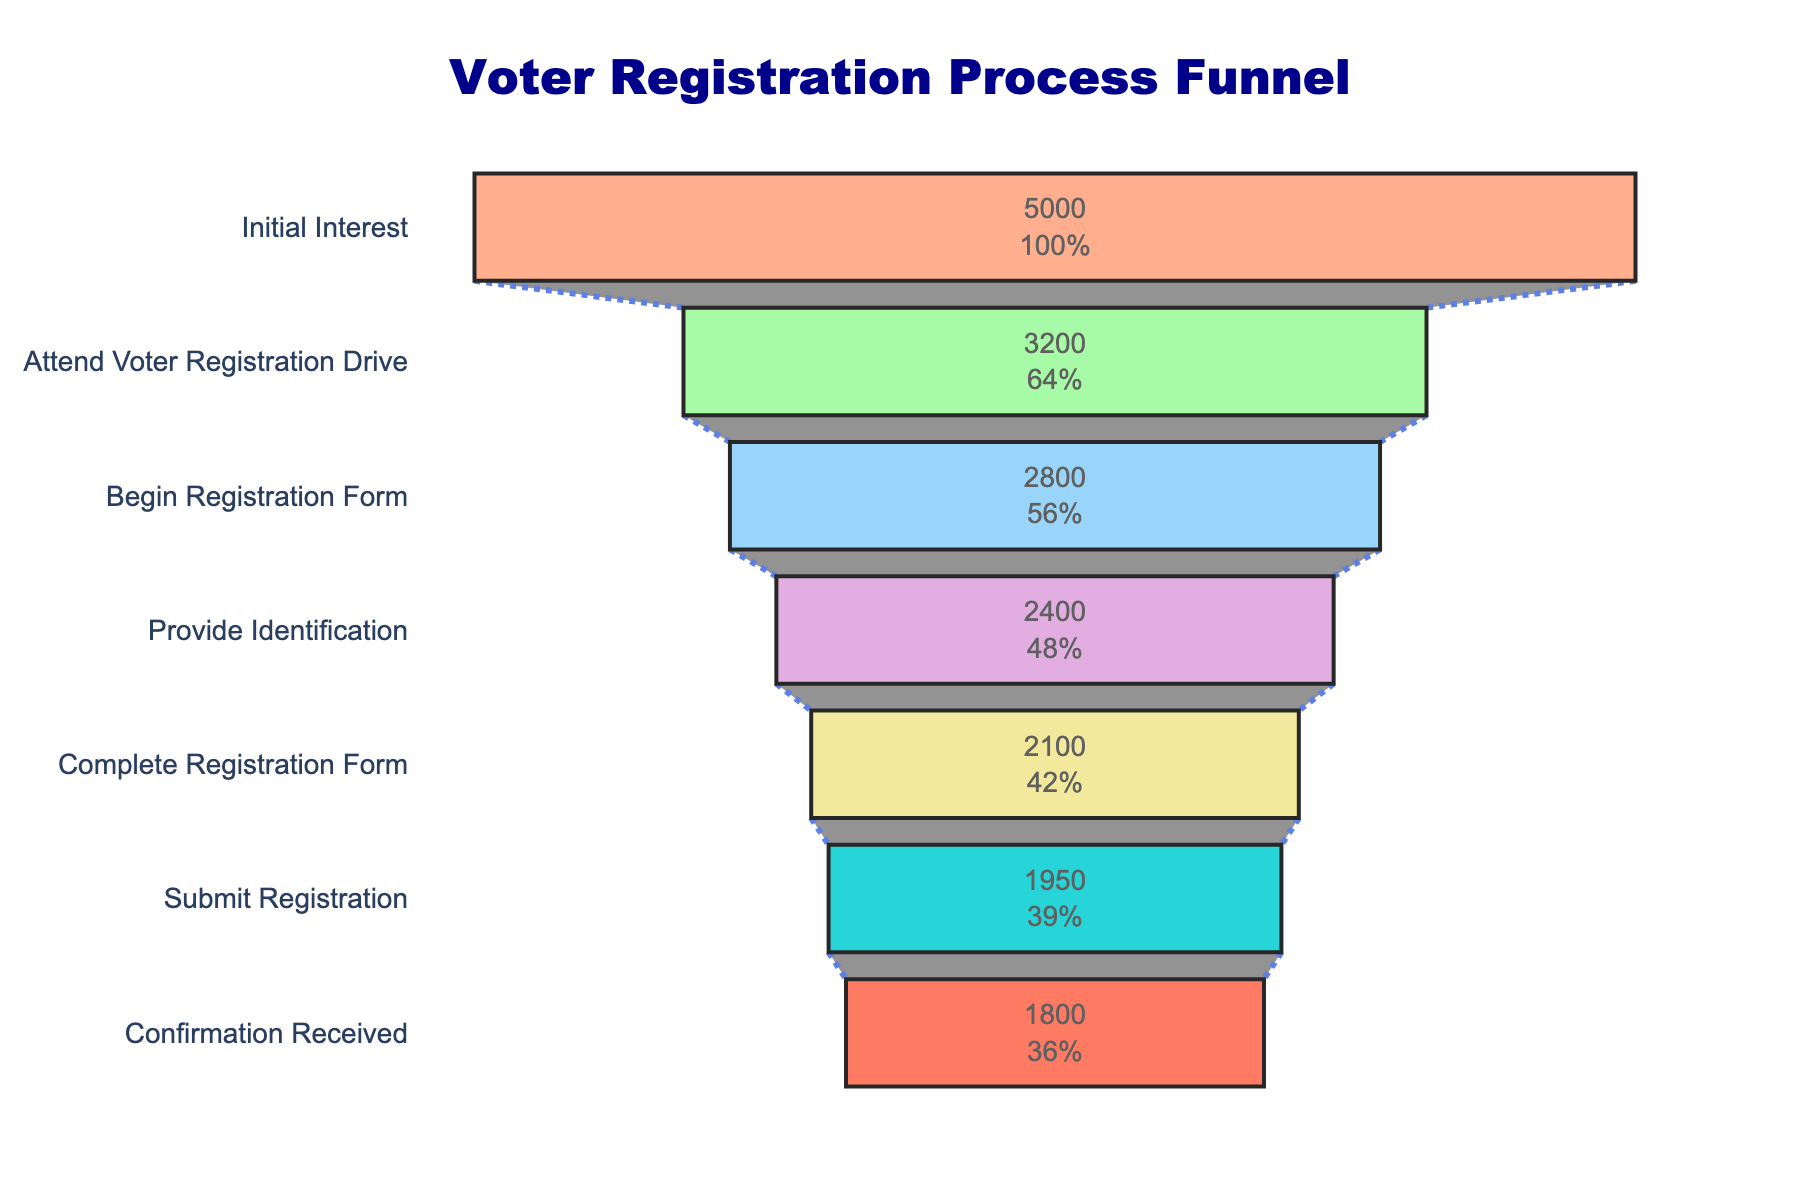What's the title of the figure? The title of the figure is located at the top center and provides a summary of what the figure represents. It reads "Voter Registration Process Funnel".
Answer: Voter Registration Process Funnel What stage has the most significant decrease in the number of people? To find the stage with the most significant decrease, we look for the largest drop in values between successive stages. The largest drop is between "Initial Interest" (5000) and "Attend Voter Registration Drive" (3200), a decrease of 1800 people.
Answer: Attend Voter Registration Drive Which stage has the fewest number of people? To find the stage with the fewest number of people, we examine the values for each stage and identify the smallest value. The smallest value is at the final stage, "Confirmation Received" with 1800 people.
Answer: Confirmation Received What percentage of people who initially showed interest completed the registration form? To find this percentage, we take the number of people who completed the registration form (2100) and divide it by the initial interest (5000), then multiply by 100. (2100/5000) * 100 = 42%.
Answer: 42% How many more people submit their registration than those who provide identification? To determine the difference, subtract the number of people who provide identification (2400) from those who submit registration (1950). 2400 - 1950 = 450.
Answer: 450 What is the average number of people per stage? To calculate the average, sum the number of people across all stages and divide by the number of stages. Sum: 5000 + 3200 + 2800 + 2400 + 2100 + 1950 + 1800 = 19250. Number of stages: 7. Average = 19250 / 7 ≈ 2750.
Answer: 2750 Which stage shows the smallest drop in the number of people from the previous stage? To find this, we calculate the difference between each successive stage and identify the smallest drop. "Complete Registration Form" to "Submit Registration" is 2100 to 1950, a decrease of 150, which is the smallest drop.
Answer: Submit Registration What percentage of people who provided identification received confirmation? To find this percentage, we divide the number of people who received confirmation (1800) by those who provided identification (2400) and multiply by 100. (1800/2400) * 100 = 75%.
Answer: 75% What stage follows "Begin Registration Form"? To identify the stage following "Begin Registration Form," we look at the order of stages. The stage immediately after "Begin Registration Form" is "Provide Identification".
Answer: Provide Identification If another 200 people provided identification, how many people would have completed the registration form assuming the same percentage drop? Currently, 2400 people provided identification, and 2100 completed the form. First, find the drop percentage: (2400 - 2100)/2400 ≈ 12.5%. If 200 more people provided identification, the new total providing identification would be 2400 + 200 = 2600. Applying the same drop: 12.5% of 2600 is 325. Expected to complete: 2600 - 325 = 2275.
Answer: 2275 